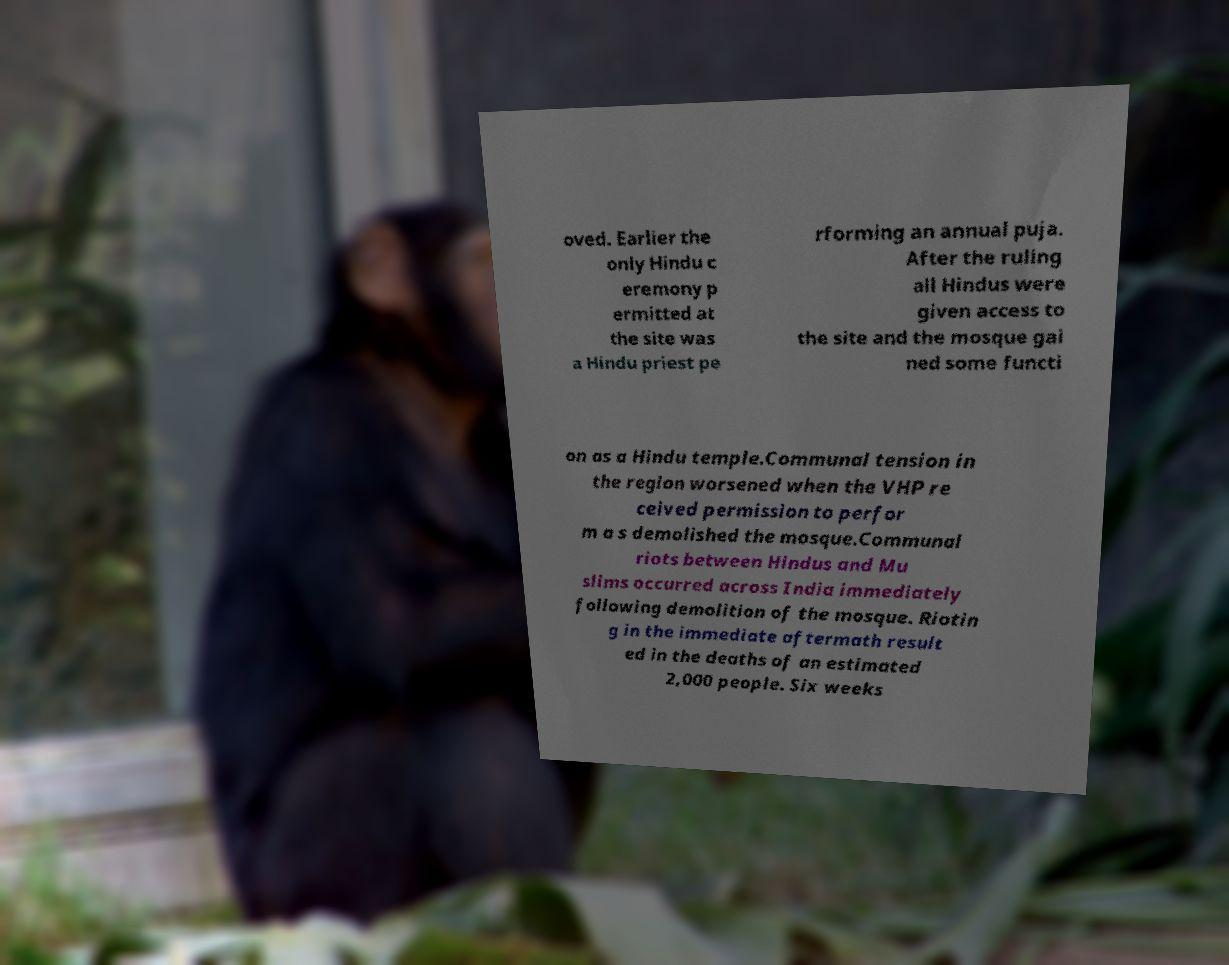Could you extract and type out the text from this image? oved. Earlier the only Hindu c eremony p ermitted at the site was a Hindu priest pe rforming an annual puja. After the ruling all Hindus were given access to the site and the mosque gai ned some functi on as a Hindu temple.Communal tension in the region worsened when the VHP re ceived permission to perfor m a s demolished the mosque.Communal riots between Hindus and Mu slims occurred across India immediately following demolition of the mosque. Riotin g in the immediate aftermath result ed in the deaths of an estimated 2,000 people. Six weeks 